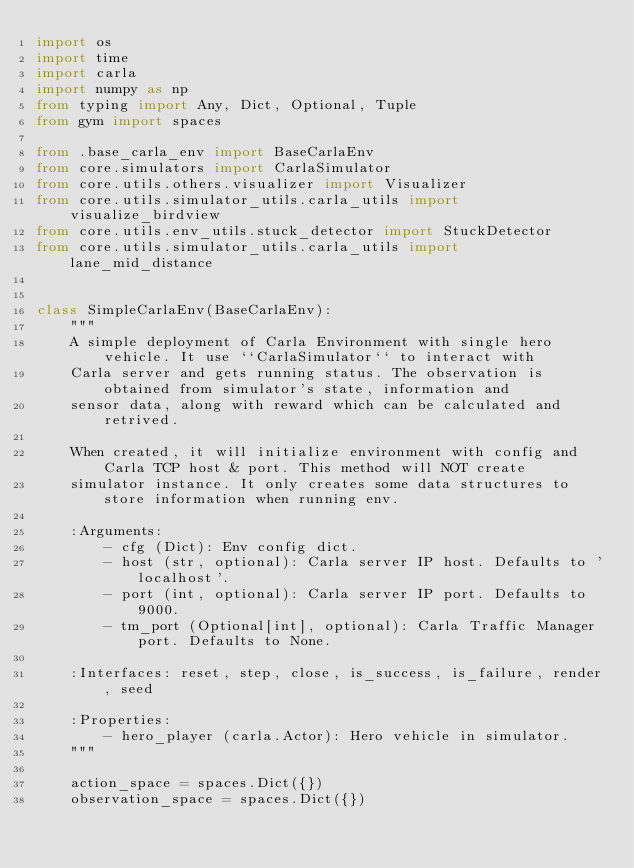<code> <loc_0><loc_0><loc_500><loc_500><_Python_>import os
import time
import carla
import numpy as np
from typing import Any, Dict, Optional, Tuple
from gym import spaces

from .base_carla_env import BaseCarlaEnv
from core.simulators import CarlaSimulator
from core.utils.others.visualizer import Visualizer
from core.utils.simulator_utils.carla_utils import visualize_birdview
from core.utils.env_utils.stuck_detector import StuckDetector
from core.utils.simulator_utils.carla_utils import lane_mid_distance


class SimpleCarlaEnv(BaseCarlaEnv):
    """
    A simple deployment of Carla Environment with single hero vehicle. It use ``CarlaSimulator`` to interact with
    Carla server and gets running status. The observation is obtained from simulator's state, information and
    sensor data, along with reward which can be calculated and retrived.

    When created, it will initialize environment with config and Carla TCP host & port. This method will NOT create
    simulator instance. It only creates some data structures to store information when running env.

    :Arguments:
        - cfg (Dict): Env config dict.
        - host (str, optional): Carla server IP host. Defaults to 'localhost'.
        - port (int, optional): Carla server IP port. Defaults to 9000.
        - tm_port (Optional[int], optional): Carla Traffic Manager port. Defaults to None.

    :Interfaces: reset, step, close, is_success, is_failure, render, seed

    :Properties:
        - hero_player (carla.Actor): Hero vehicle in simulator.
    """

    action_space = spaces.Dict({})
    observation_space = spaces.Dict({})</code> 